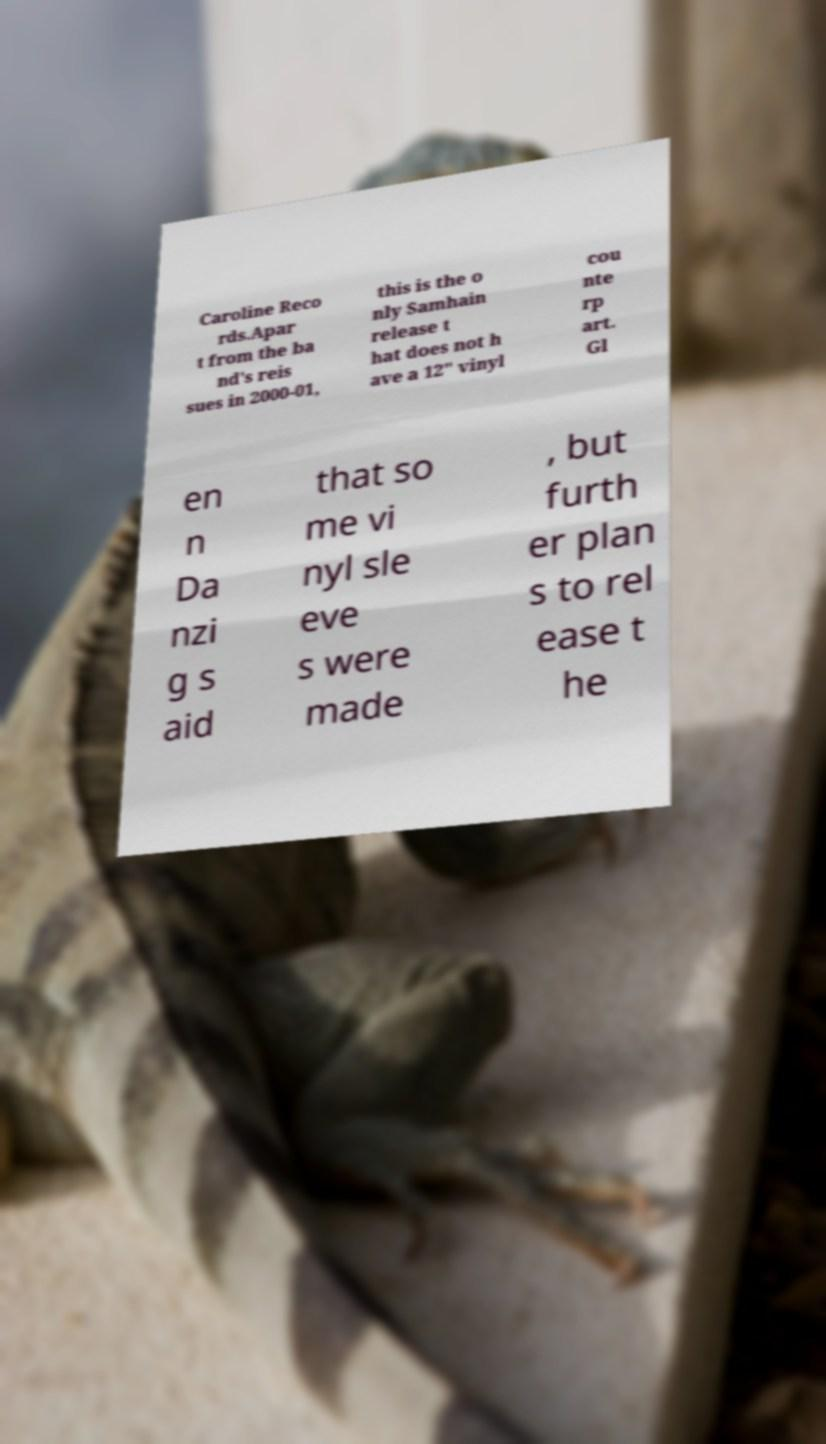Could you extract and type out the text from this image? Caroline Reco rds.Apar t from the ba nd's reis sues in 2000-01, this is the o nly Samhain release t hat does not h ave a 12" vinyl cou nte rp art. Gl en n Da nzi g s aid that so me vi nyl sle eve s were made , but furth er plan s to rel ease t he 